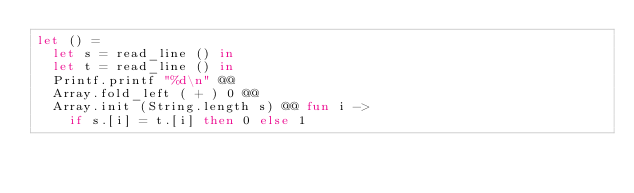Convert code to text. <code><loc_0><loc_0><loc_500><loc_500><_OCaml_>let () =
  let s = read_line () in
  let t = read_line () in
  Printf.printf "%d\n" @@
  Array.fold_left ( + ) 0 @@
  Array.init (String.length s) @@ fun i ->
    if s.[i] = t.[i] then 0 else 1
</code> 